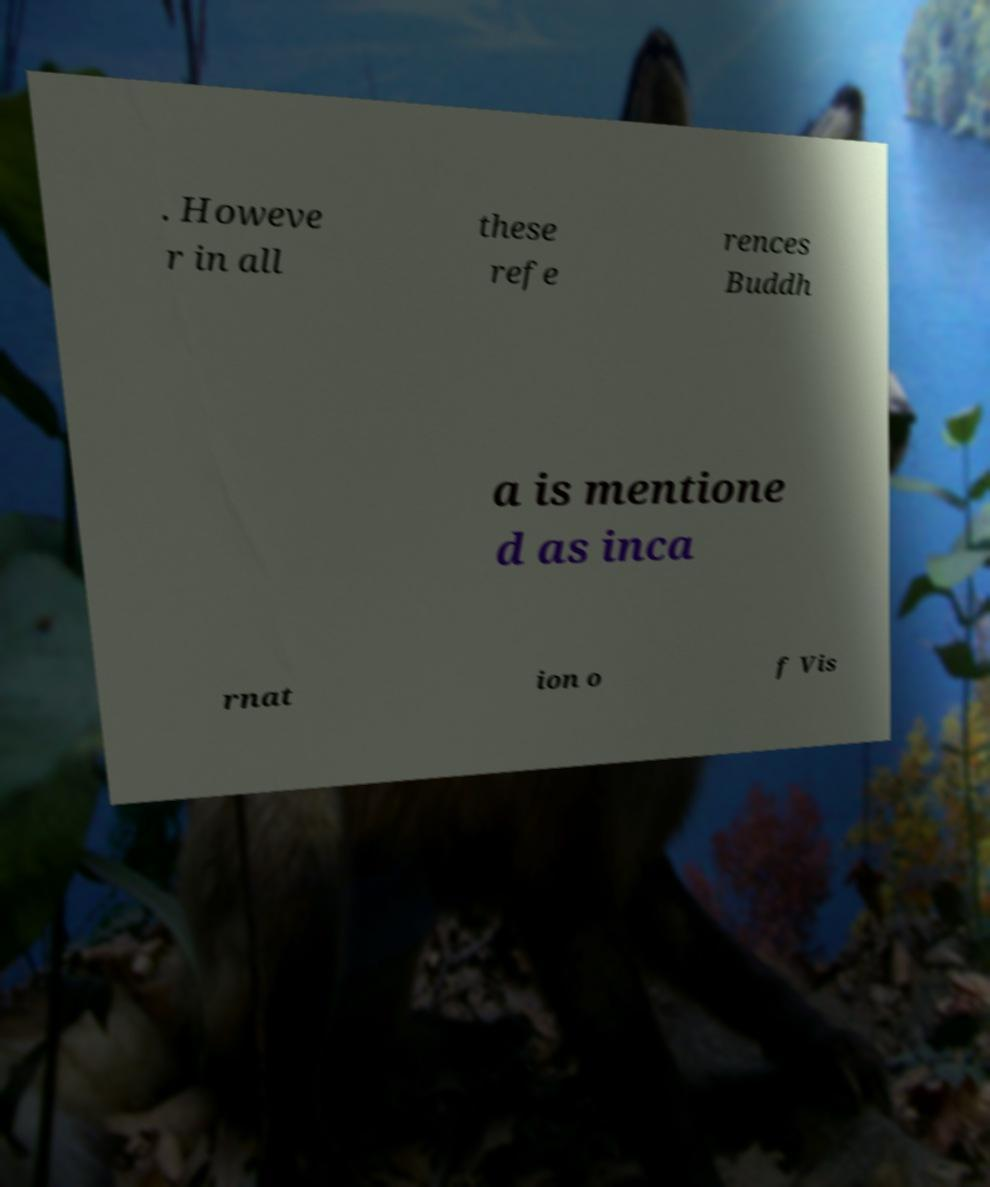Can you read and provide the text displayed in the image?This photo seems to have some interesting text. Can you extract and type it out for me? . Howeve r in all these refe rences Buddh a is mentione d as inca rnat ion o f Vis 